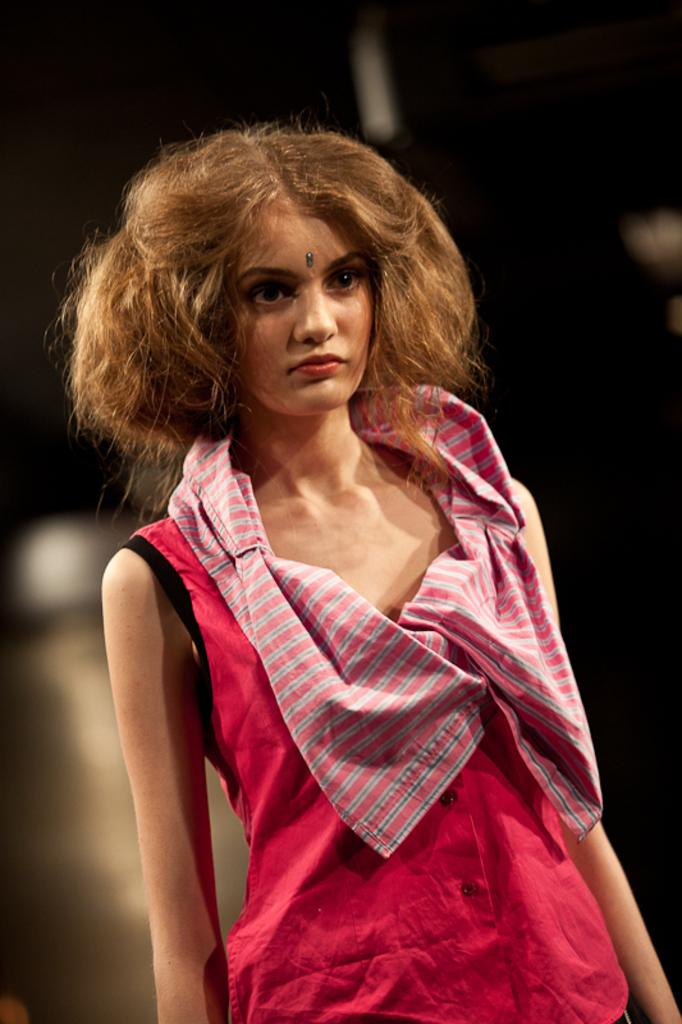Who is the main subject in the image? There is a woman in the image. Can you describe the woman's hair? The woman has short brown hair. What is the woman wearing? The woman is wearing a red shirt and a scarf. What is the woman doing in the image? The woman is standing and looking somewhere. What type of offer is the squirrel making to the woman in the image? There is no squirrel present in the image, so no offer can be made. 